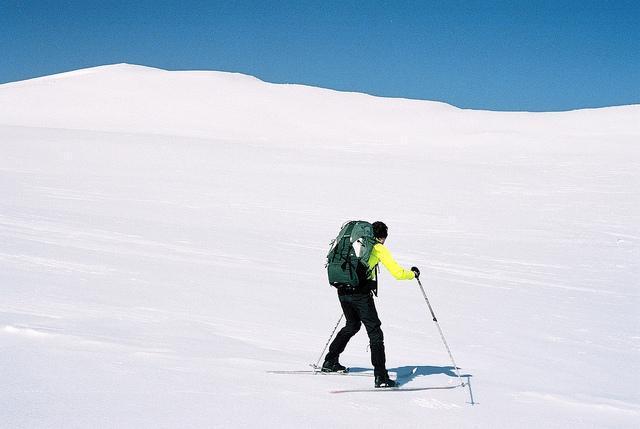How many loading doors does the bus have?
Give a very brief answer. 0. 